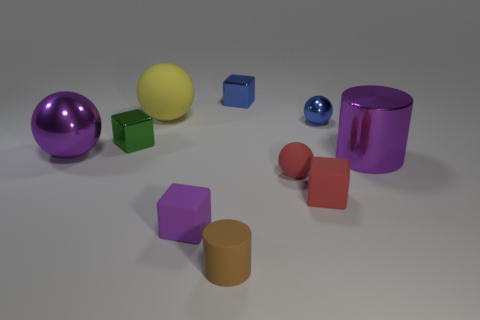Do the purple cube and the rubber sphere that is to the right of the brown matte object have the same size?
Offer a terse response. Yes. What number of objects are either small blue things or tiny brown matte balls?
Your answer should be very brief. 2. Are there any small blue spheres made of the same material as the small green cube?
Your answer should be very brief. Yes. The sphere that is the same color as the metal cylinder is what size?
Give a very brief answer. Large. What is the color of the metal ball behind the shiny ball on the left side of the red cube?
Keep it short and to the point. Blue. Is the brown rubber object the same size as the purple sphere?
Provide a succinct answer. No. How many spheres are either yellow matte things or purple metallic things?
Offer a very short reply. 2. There is a shiny sphere to the left of the green thing; what number of big purple shiny cylinders are left of it?
Provide a short and direct response. 0. Is the green metal thing the same shape as the small purple object?
Ensure brevity in your answer.  Yes. What size is the other object that is the same shape as the tiny brown matte object?
Your answer should be compact. Large. 